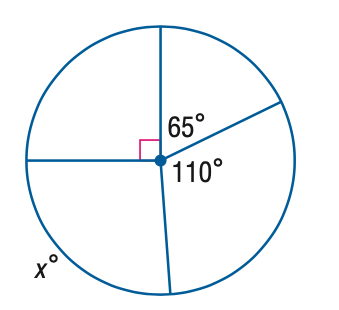Question: Find the value of x.
Choices:
A. 65
B. 90
C. 95
D. 110
Answer with the letter. Answer: C 